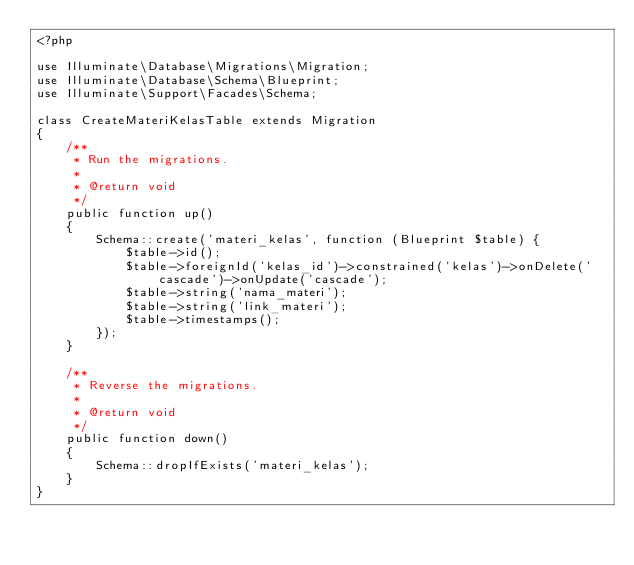<code> <loc_0><loc_0><loc_500><loc_500><_PHP_><?php

use Illuminate\Database\Migrations\Migration;
use Illuminate\Database\Schema\Blueprint;
use Illuminate\Support\Facades\Schema;

class CreateMateriKelasTable extends Migration
{
    /**
     * Run the migrations.
     *
     * @return void
     */
    public function up()
    {
        Schema::create('materi_kelas', function (Blueprint $table) {
            $table->id();
            $table->foreignId('kelas_id')->constrained('kelas')->onDelete('cascade')->onUpdate('cascade');
            $table->string('nama_materi');
            $table->string('link_materi');
            $table->timestamps();
        });
    }

    /**
     * Reverse the migrations.
     *
     * @return void
     */
    public function down()
    {
        Schema::dropIfExists('materi_kelas');
    }
}
</code> 